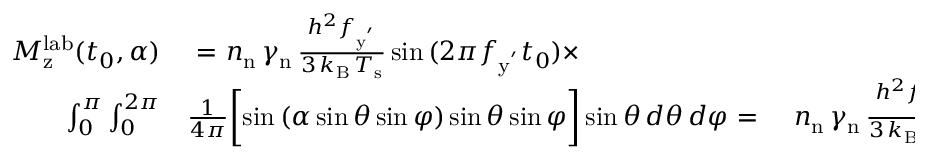Convert formula to latex. <formula><loc_0><loc_0><loc_500><loc_500>\begin{array} { r l r } { M _ { z } ^ { l a b } ( { t _ { 0 } , \alpha } ) } & { = } n _ { n } \, \gamma _ { n } \, \frac { h ^ { 2 } f _ { y ^ { ^ { \prime } } } } { 3 \, k _ { B } \, T _ { s } } \sin { ( 2 \pi f _ { y ^ { ^ { \prime } } } t _ { 0 } ) } \times } \\ { \int _ { 0 } ^ { \pi } \int _ { 0 } ^ { 2 \pi } } & \frac { 1 } { 4 \pi } \left [ \sin { ( \alpha \sin { \theta } \sin { \varphi } ) } \sin { \theta } \sin { \varphi } \right ] \sin { \theta } \, d \theta \, d \varphi \ { = } } & { n _ { n } \, \gamma _ { n } \, \frac { h ^ { 2 } f _ { y ^ { ^ { \prime } } } } { 3 \, k _ { B } \, T _ { s } } \sin { ( 2 \pi f _ { y ^ { ^ { \prime } } } t _ { 0 } ) } \sqrt { \frac { \pi } { 2 \alpha } } \, J _ { 3 / 2 } ( \alpha ) , } \end{array}</formula> 